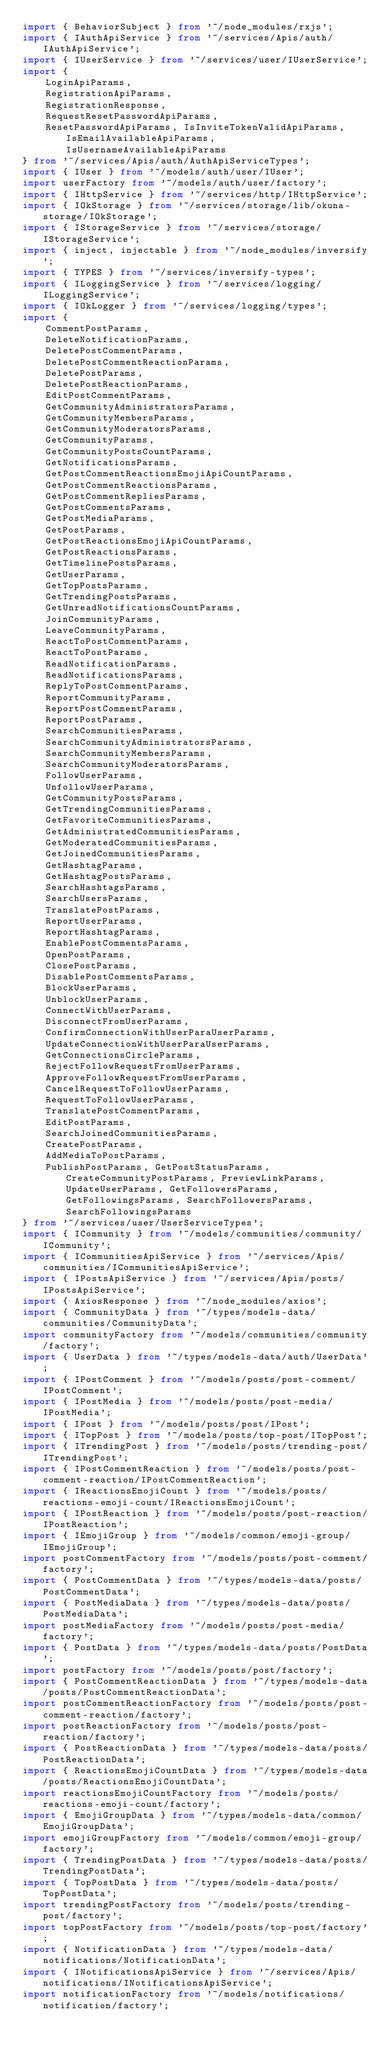Convert code to text. <code><loc_0><loc_0><loc_500><loc_500><_TypeScript_>import { BehaviorSubject } from '~/node_modules/rxjs';
import { IAuthApiService } from '~/services/Apis/auth/IAuthApiService';
import { IUserService } from '~/services/user/IUserService';
import {
    LoginApiParams,
    RegistrationApiParams,
    RegistrationResponse,
    RequestResetPasswordApiParams,
    ResetPasswordApiParams, IsInviteTokenValidApiParams, IsEmailAvailableApiParams, IsUsernameAvailableApiParams
} from '~/services/Apis/auth/AuthApiServiceTypes';
import { IUser } from '~/models/auth/user/IUser';
import userFactory from '~/models/auth/user/factory';
import { IHttpService } from '~/services/http/IHttpService';
import { IOkStorage } from '~/services/storage/lib/okuna-storage/IOkStorage';
import { IStorageService } from '~/services/storage/IStorageService';
import { inject, injectable } from '~/node_modules/inversify';
import { TYPES } from '~/services/inversify-types';
import { ILoggingService } from '~/services/logging/ILoggingService';
import { IOkLogger } from '~/services/logging/types';
import {
    CommentPostParams,
    DeleteNotificationParams,
    DeletePostCommentParams,
    DeletePostCommentReactionParams,
    DeletePostParams,
    DeletePostReactionParams,
    EditPostCommentParams,
    GetCommunityAdministratorsParams,
    GetCommunityMembersParams,
    GetCommunityModeratorsParams,
    GetCommunityParams,
    GetCommunityPostsCountParams,
    GetNotificationsParams,
    GetPostCommentReactionsEmojiApiCountParams,
    GetPostCommentReactionsParams,
    GetPostCommentRepliesParams,
    GetPostCommentsParams,
    GetPostMediaParams,
    GetPostParams,
    GetPostReactionsEmojiApiCountParams,
    GetPostReactionsParams,
    GetTimelinePostsParams,
    GetUserParams,
    GetTopPostsParams,
    GetTrendingPostsParams,
    GetUnreadNotificationsCountParams,
    JoinCommunityParams,
    LeaveCommunityParams,
    ReactToPostCommentParams,
    ReactToPostParams,
    ReadNotificationParams,
    ReadNotificationsParams,
    ReplyToPostCommentParams,
    ReportCommunityParams,
    ReportPostCommentParams,
    ReportPostParams,
    SearchCommunitiesParams,
    SearchCommunityAdministratorsParams,
    SearchCommunityMembersParams,
    SearchCommunityModeratorsParams,
    FollowUserParams,
    UnfollowUserParams,
    GetCommunityPostsParams,
    GetTrendingCommunitiesParams,
    GetFavoriteCommunitiesParams,
    GetAdministratedCommunitiesParams,
    GetModeratedCommunitiesParams,
    GetJoinedCommunitiesParams,
    GetHashtagParams,
    GetHashtagPostsParams,
    SearchHashtagsParams,
    SearchUsersParams,
    TranslatePostParams,
    ReportUserParams,
    ReportHashtagParams,
    EnablePostCommentsParams,
    OpenPostParams,
    ClosePostParams,
    DisablePostCommentsParams,
    BlockUserParams,
    UnblockUserParams,
    ConnectWithUserParams,
    DisconnectFromUserParams,
    ConfirmConnectionWithUserParaUserParams,
    UpdateConnectionWithUserParaUserParams,
    GetConnectionsCircleParams,
    RejectFollowRequestFromUserParams,
    ApproveFollowRequestFromUserParams,
    CancelRequestToFollowUserParams,
    RequestToFollowUserParams,
    TranslatePostCommentParams,
    EditPostParams,
    SearchJoinedCommunitiesParams,
    CreatePostParams,
    AddMediaToPostParams,
    PublishPostParams, GetPostStatusParams, CreateCommunityPostParams, PreviewLinkParams, UpdateUserParams, GetFollowersParams, GetFollowingsParams, SearchFollowersParams, SearchFollowingsParams
} from '~/services/user/UserServiceTypes';
import { ICommunity } from '~/models/communities/community/ICommunity';
import { ICommunitiesApiService } from '~/services/Apis/communities/ICommunitiesApiService';
import { IPostsApiService } from '~/services/Apis/posts/IPostsApiService';
import { AxiosResponse } from '~/node_modules/axios';
import { CommunityData } from '~/types/models-data/communities/CommunityData';
import communityFactory from '~/models/communities/community/factory';
import { UserData } from '~/types/models-data/auth/UserData';
import { IPostComment } from '~/models/posts/post-comment/IPostComment';
import { IPostMedia } from '~/models/posts/post-media/IPostMedia';
import { IPost } from '~/models/posts/post/IPost';
import { ITopPost } from '~/models/posts/top-post/ITopPost';
import { ITrendingPost } from '~/models/posts/trending-post/ITrendingPost';
import { IPostCommentReaction } from '~/models/posts/post-comment-reaction/IPostCommentReaction';
import { IReactionsEmojiCount } from '~/models/posts/reactions-emoji-count/IReactionsEmojiCount';
import { IPostReaction } from '~/models/posts/post-reaction/IPostReaction';
import { IEmojiGroup } from '~/models/common/emoji-group/IEmojiGroup';
import postCommentFactory from '~/models/posts/post-comment/factory';
import { PostCommentData } from '~/types/models-data/posts/PostCommentData';
import { PostMediaData } from '~/types/models-data/posts/PostMediaData';
import postMediaFactory from '~/models/posts/post-media/factory';
import { PostData } from '~/types/models-data/posts/PostData';
import postFactory from '~/models/posts/post/factory';
import { PostCommentReactionData } from '~/types/models-data/posts/PostCommentReactionData';
import postCommentReactionFactory from '~/models/posts/post-comment-reaction/factory';
import postReactionFactory from '~/models/posts/post-reaction/factory';
import { PostReactionData } from '~/types/models-data/posts/PostReactionData';
import { ReactionsEmojiCountData } from '~/types/models-data/posts/ReactionsEmojiCountData';
import reactionsEmojiCountFactory from '~/models/posts/reactions-emoji-count/factory';
import { EmojiGroupData } from '~/types/models-data/common/EmojiGroupData';
import emojiGroupFactory from '~/models/common/emoji-group/factory';
import { TrendingPostData } from '~/types/models-data/posts/TrendingPostData';
import { TopPostData } from '~/types/models-data/posts/TopPostData';
import trendingPostFactory from '~/models/posts/trending-post/factory';
import topPostFactory from '~/models/posts/top-post/factory';
import { NotificationData } from '~/types/models-data/notifications/NotificationData';
import { INotificationsApiService } from '~/services/Apis/notifications/INotificationsApiService';
import notificationFactory from '~/models/notifications/notification/factory';</code> 